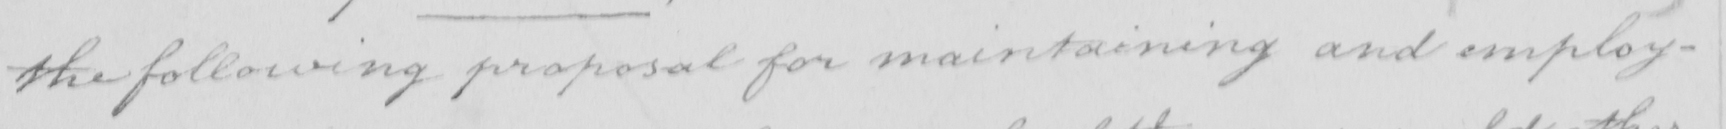Please transcribe the handwritten text in this image. the following proposal for maintaining and employ- 